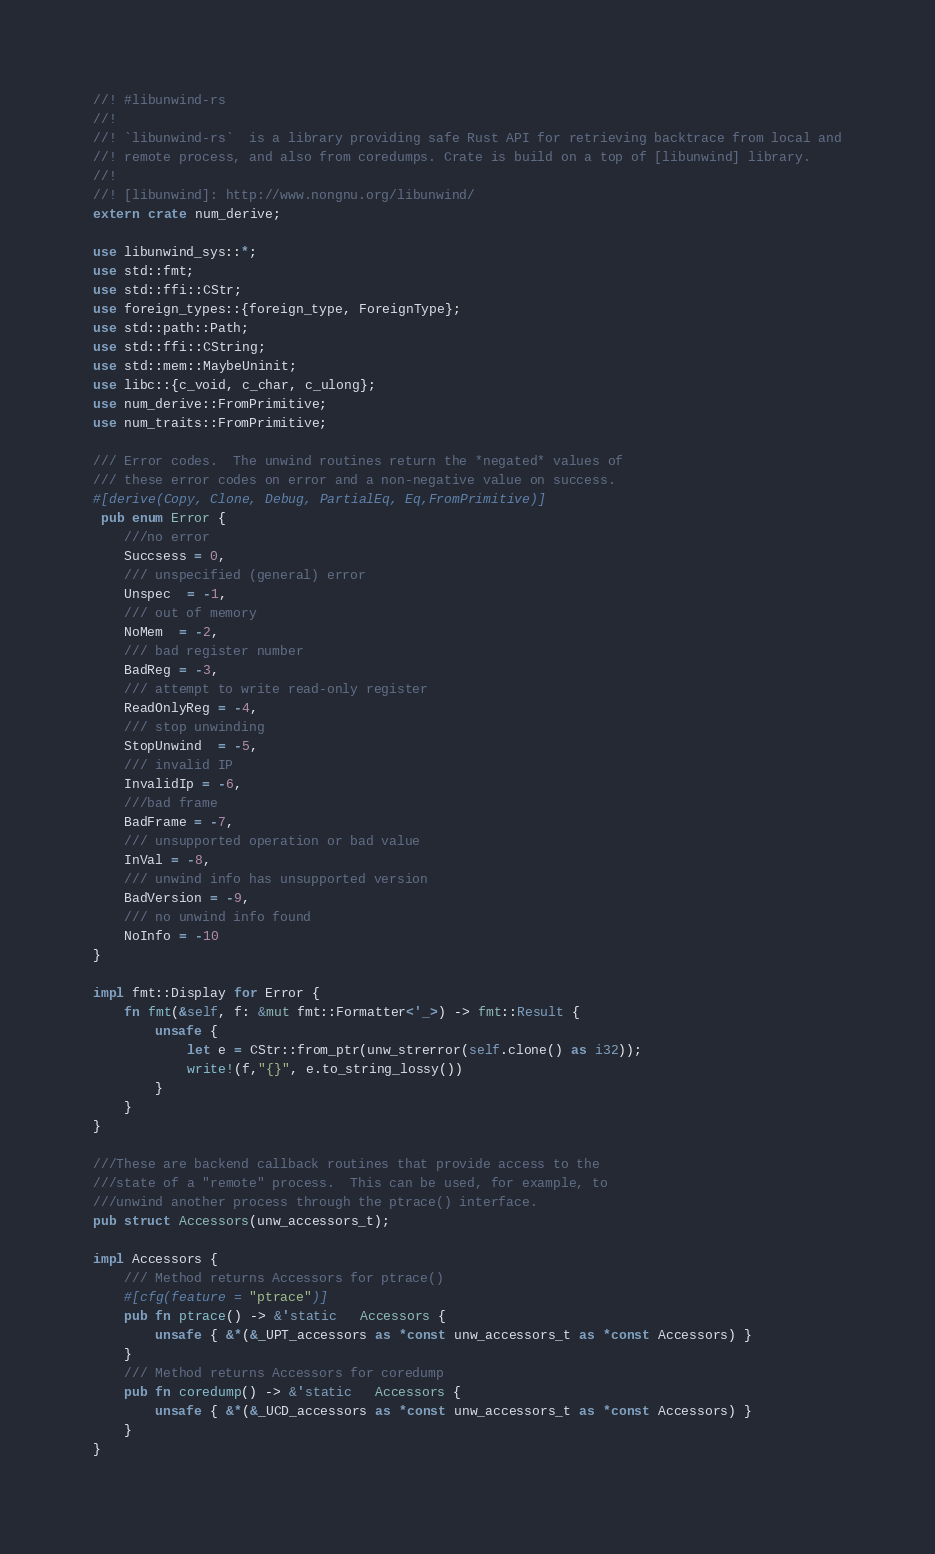Convert code to text. <code><loc_0><loc_0><loc_500><loc_500><_Rust_>//! #libunwind-rs
//!
//! `libunwind-rs`  is a library providing safe Rust API for retrieving backtrace from local and
//! remote process, and also from coredumps. Crate is build on a top of [libunwind] library.
//!
//! [libunwind]: http://www.nongnu.org/libunwind/
extern crate num_derive;

use libunwind_sys::*;
use std::fmt;
use std::ffi::CStr;
use foreign_types::{foreign_type, ForeignType};
use std::path::Path;
use std::ffi::CString;
use std::mem::MaybeUninit;
use libc::{c_void, c_char, c_ulong};
use num_derive::FromPrimitive;
use num_traits::FromPrimitive;

/// Error codes.  The unwind routines return the *negated* values of
/// these error codes on error and a non-negative value on success.
#[derive(Copy, Clone, Debug, PartialEq, Eq,FromPrimitive)]
 pub enum Error {
    ///no error
    Succsess = 0,
    /// unspecified (general) error
    Unspec  = -1,
    /// out of memory
    NoMem  = -2,
    /// bad register number
    BadReg = -3,
    /// attempt to write read-only register
    ReadOnlyReg = -4,
    /// stop unwinding
    StopUnwind  = -5,
    /// invalid IP
    InvalidIp = -6,
    ///bad frame
    BadFrame = -7,
    /// unsupported operation or bad value
    InVal = -8,
    /// unwind info has unsupported version
    BadVersion = -9,
    /// no unwind info found
    NoInfo = -10
}

impl fmt::Display for Error {
    fn fmt(&self, f: &mut fmt::Formatter<'_>) -> fmt::Result {
        unsafe {
            let e = CStr::from_ptr(unw_strerror(self.clone() as i32));
            write!(f,"{}", e.to_string_lossy())
        }
    }
}

///These are backend callback routines that provide access to the
///state of a "remote" process.  This can be used, for example, to
///unwind another process through the ptrace() interface.
pub struct Accessors(unw_accessors_t);

impl Accessors {
    /// Method returns Accessors for ptrace()
    #[cfg(feature = "ptrace")]
    pub fn ptrace() -> &'static   Accessors {
        unsafe { &*(&_UPT_accessors as *const unw_accessors_t as *const Accessors) }
    }
    /// Method returns Accessors for coredump
    pub fn coredump() -> &'static   Accessors {
        unsafe { &*(&_UCD_accessors as *const unw_accessors_t as *const Accessors) }
    }
}</code> 